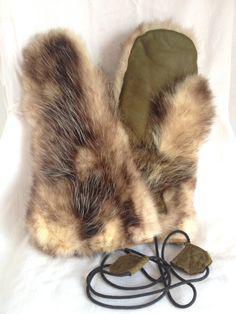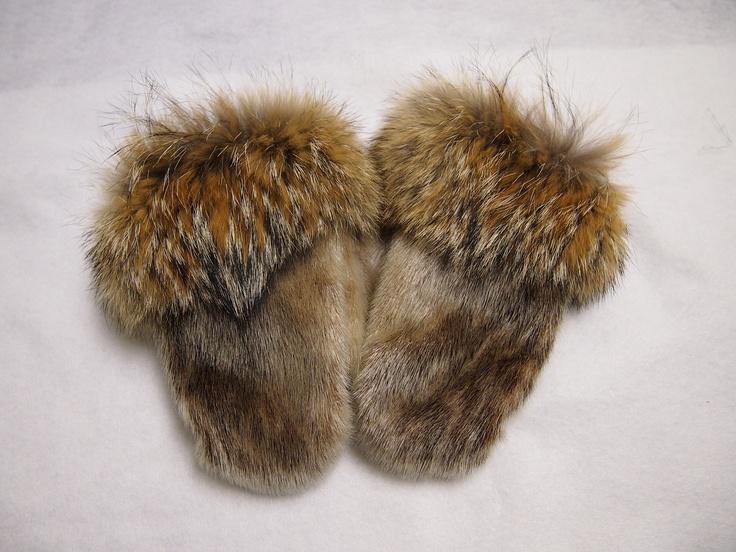The first image is the image on the left, the second image is the image on the right. Given the left and right images, does the statement "A tangled cord is part of one image of mitts." hold true? Answer yes or no. Yes. 